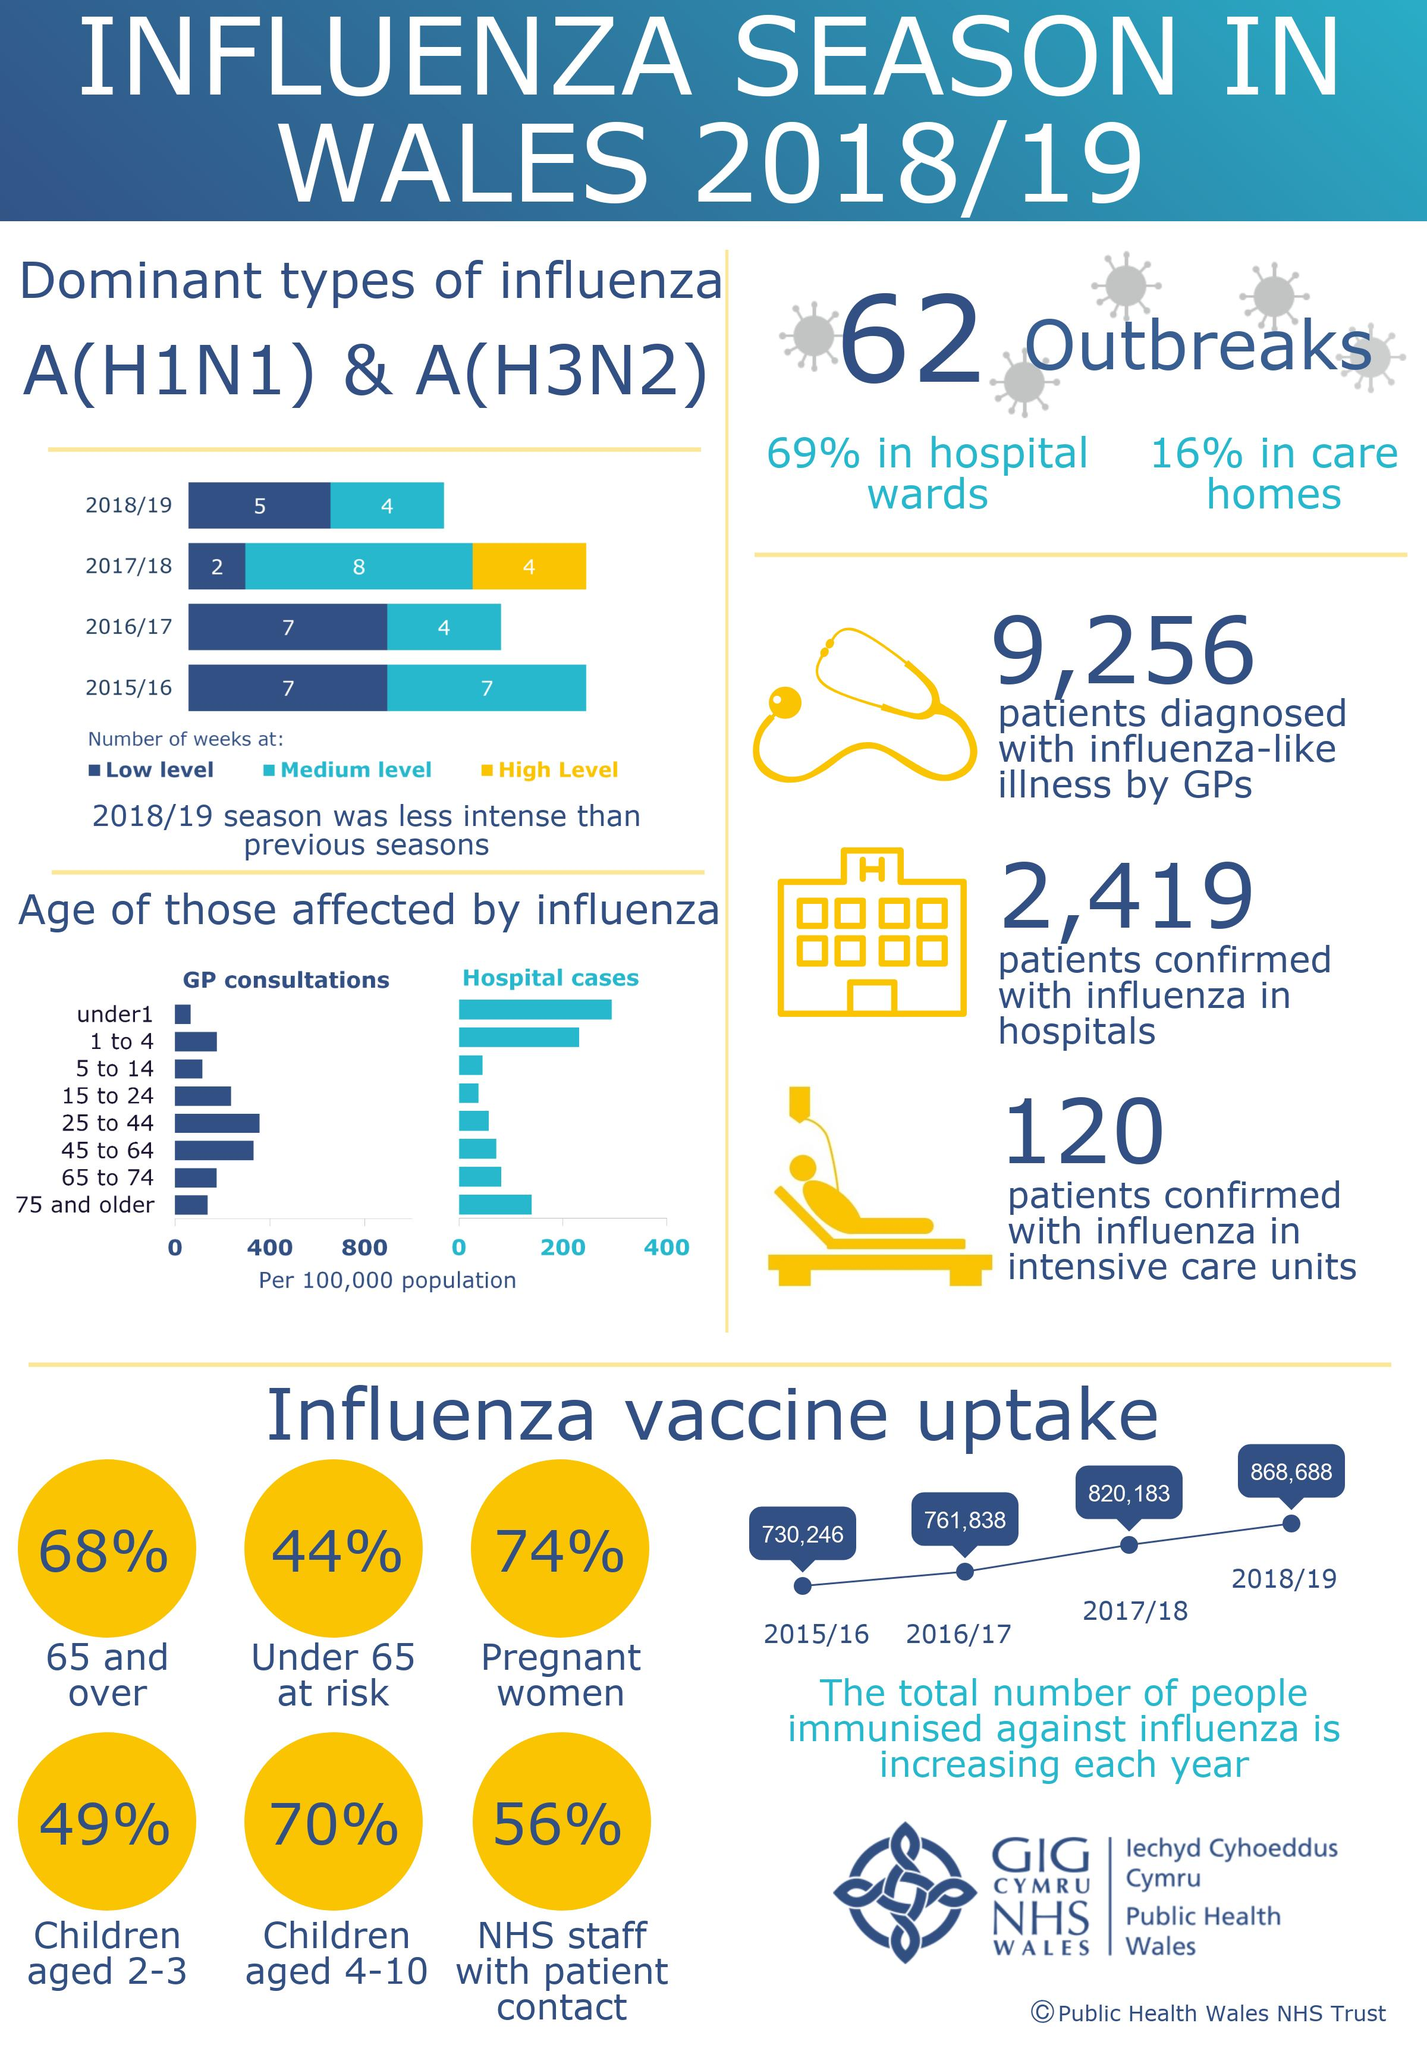Highlight a few significant elements in this photo. In the bar chart, the yellow bar represents high level. According to recent data, 68% of senior citizens have been immunized against influenza. This is an important statistic as elderly individuals are at a higher risk of serious complications from the flu. It is important for healthcare providers and public health officials to continue to prioritize immunization efforts for this population. The number of people immunized against influenza increased by 48,505 from the 2017/18 to the 2018/19 season. A recent survey has shown that a majority of expectant mothers, 74%, have been immunized. This indicates a high level of awareness and commitment to protecting the health of both the mother and the unborn child. 